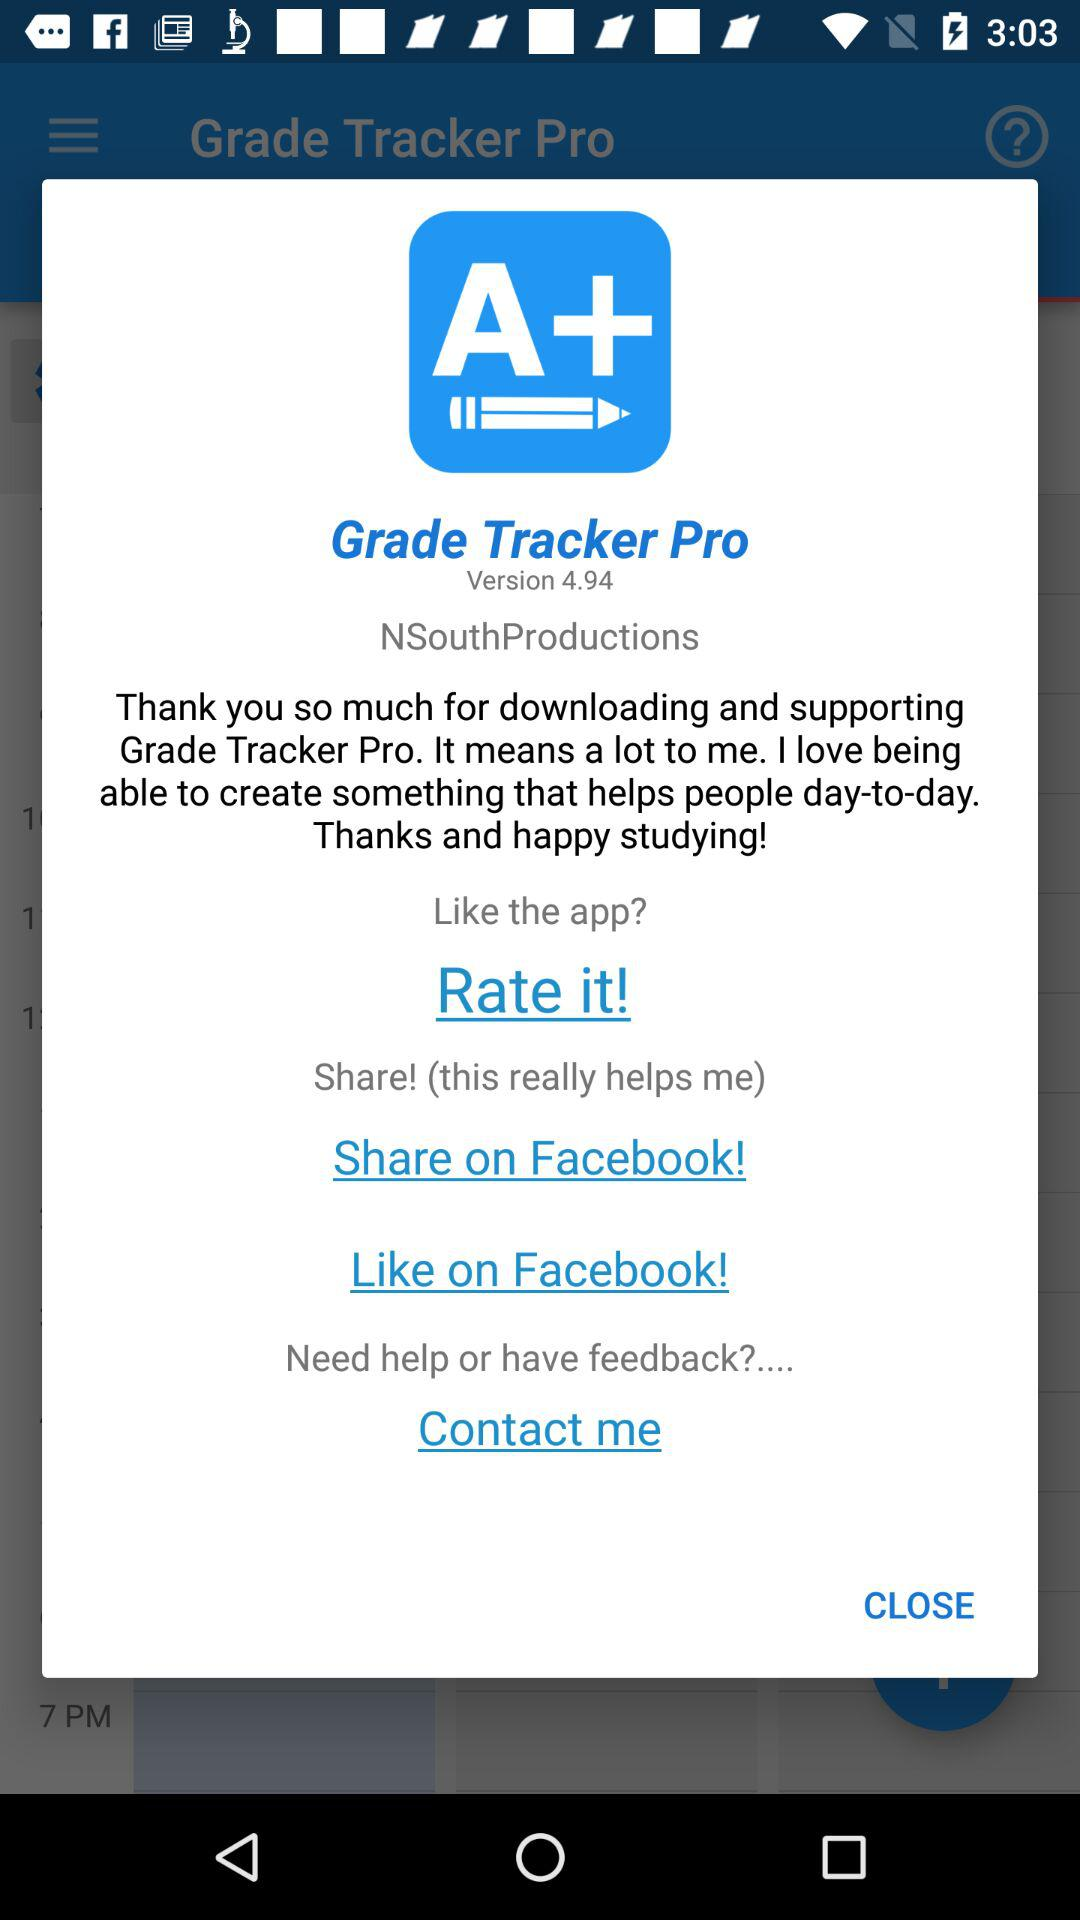What version is used? The used version is 4.94. 